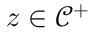Convert formula to latex. <formula><loc_0><loc_0><loc_500><loc_500>z \in \mathcal { C } ^ { + }</formula> 